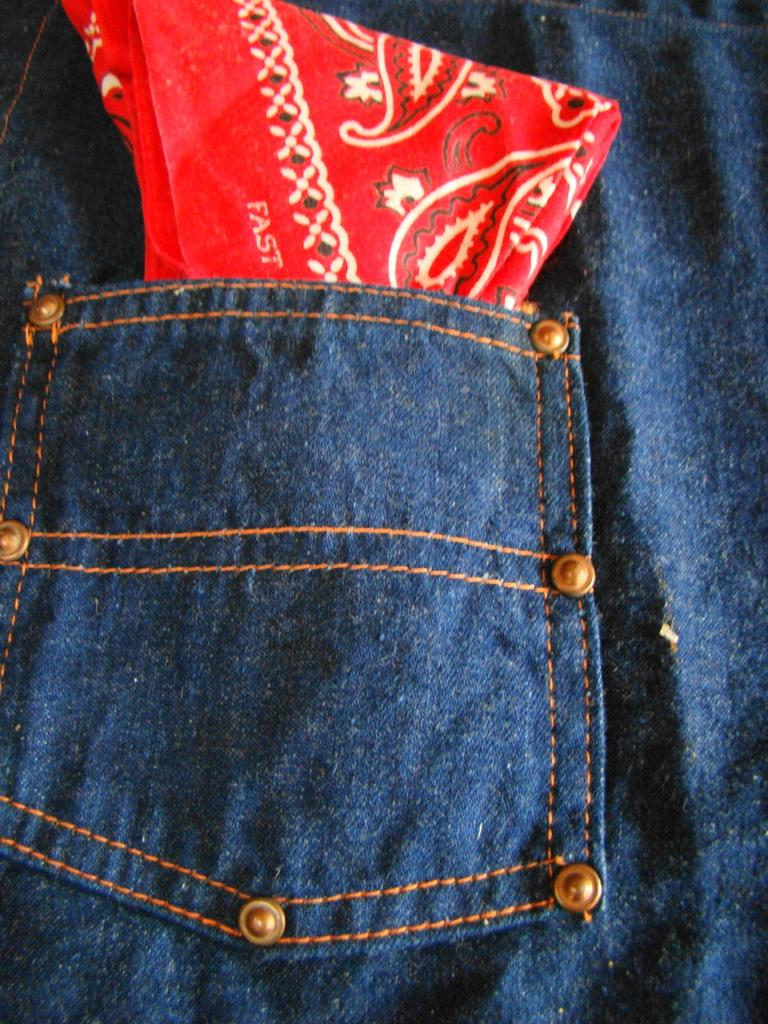What type of clothing is visible in the image? There is a pair of blue jeans in the image. What is inside the pocket of the jeans? There is a red cloth in the pocket of the jeans. What type of muscle can be seen flexing in the image? There is no muscle visible in the image; it only features a pair of blue jeans with a red cloth in the pocket. 